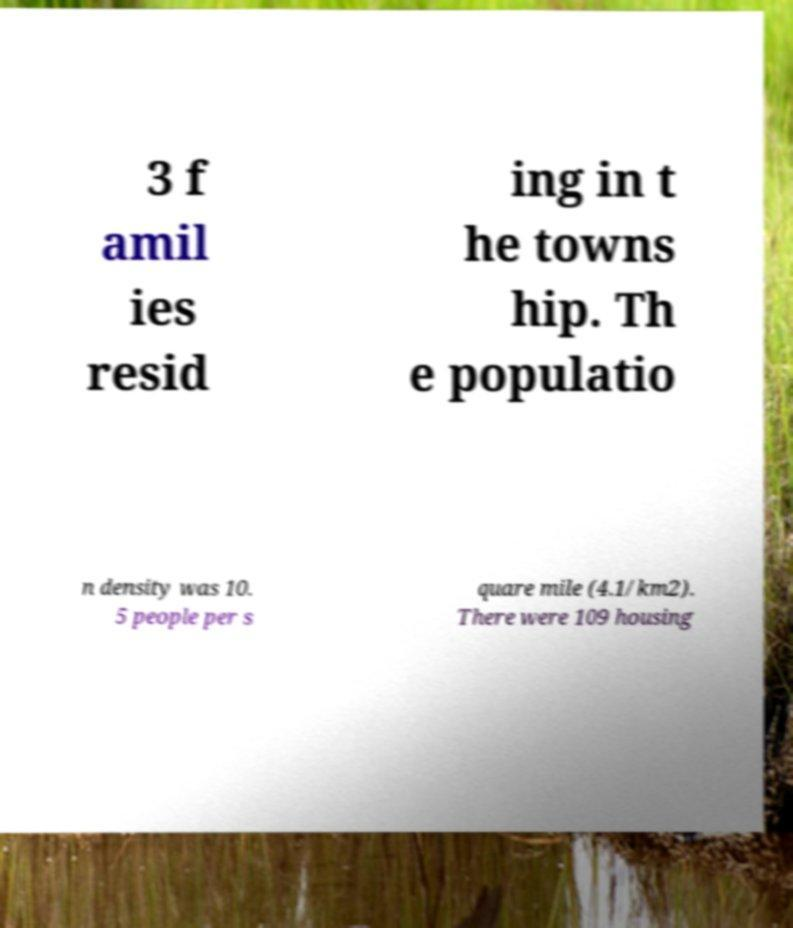Can you accurately transcribe the text from the provided image for me? 3 f amil ies resid ing in t he towns hip. Th e populatio n density was 10. 5 people per s quare mile (4.1/km2). There were 109 housing 